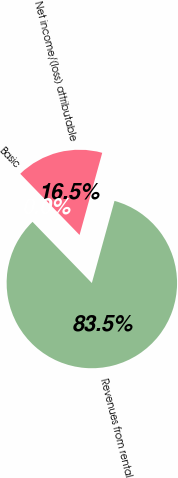Convert chart. <chart><loc_0><loc_0><loc_500><loc_500><pie_chart><fcel>Revenues from rental<fcel>Net income/(loss) attributable<fcel>Basic<nl><fcel>83.46%<fcel>16.54%<fcel>0.0%<nl></chart> 